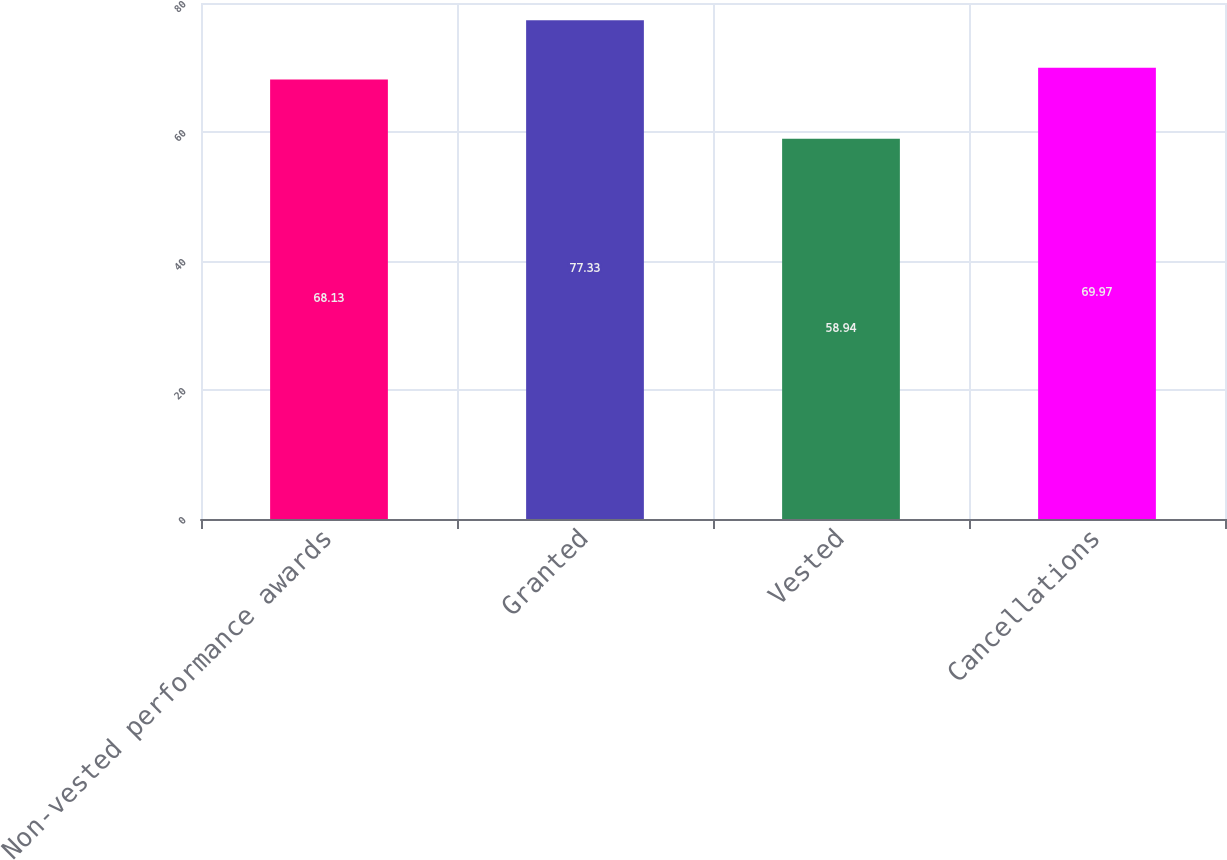Convert chart to OTSL. <chart><loc_0><loc_0><loc_500><loc_500><bar_chart><fcel>Non-vested performance awards<fcel>Granted<fcel>Vested<fcel>Cancellations<nl><fcel>68.13<fcel>77.33<fcel>58.94<fcel>69.97<nl></chart> 